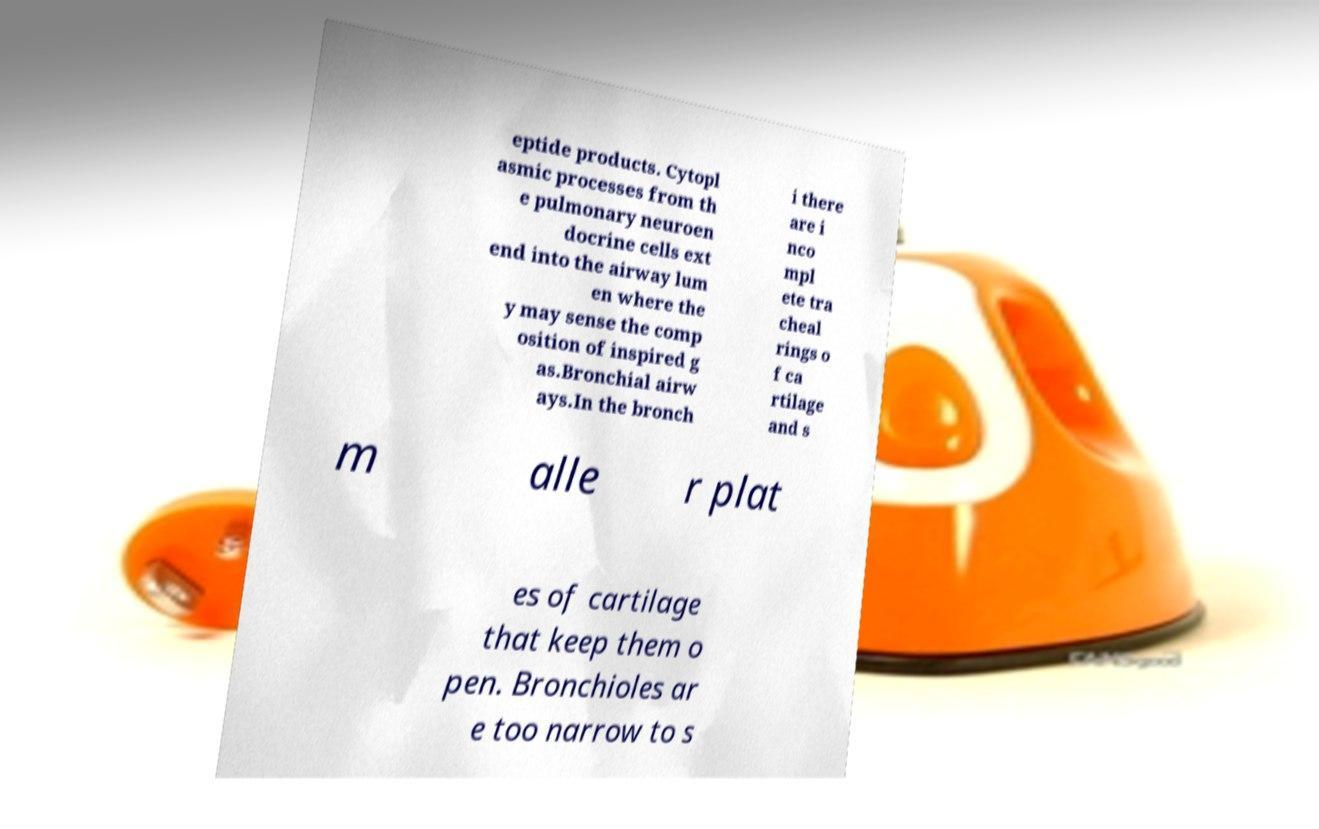For documentation purposes, I need the text within this image transcribed. Could you provide that? eptide products. Cytopl asmic processes from th e pulmonary neuroen docrine cells ext end into the airway lum en where the y may sense the comp osition of inspired g as.Bronchial airw ays.In the bronch i there are i nco mpl ete tra cheal rings o f ca rtilage and s m alle r plat es of cartilage that keep them o pen. Bronchioles ar e too narrow to s 